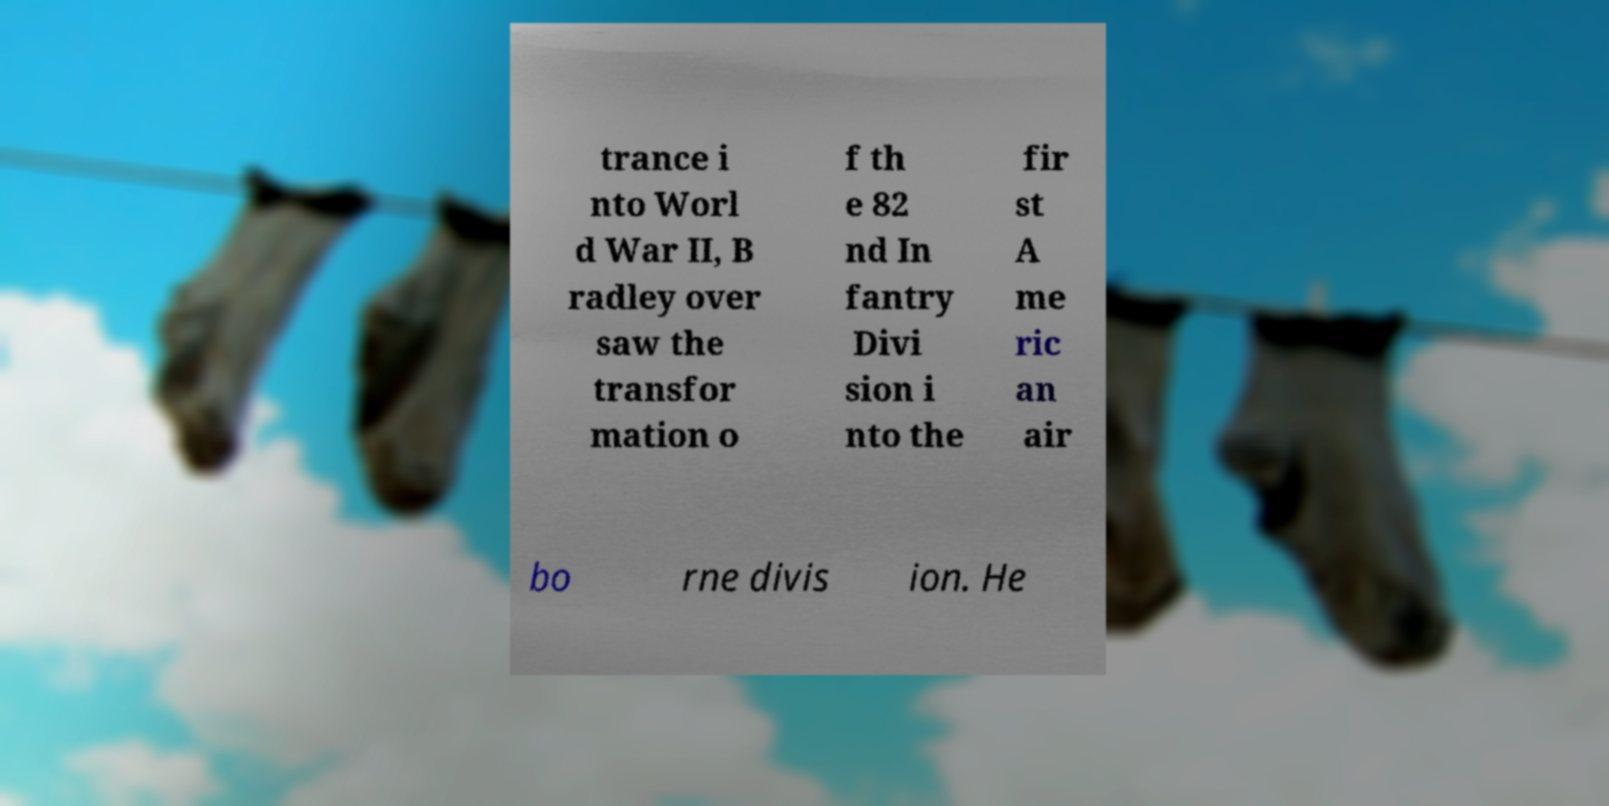Please read and relay the text visible in this image. What does it say? trance i nto Worl d War II, B radley over saw the transfor mation o f th e 82 nd In fantry Divi sion i nto the fir st A me ric an air bo rne divis ion. He 